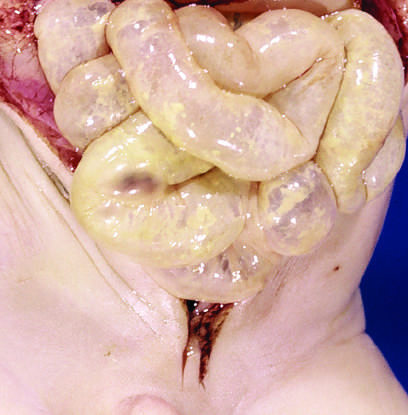what implies impending perforation?
Answer the question using a single word or phrase. The entire small bowel was markedly distended and perilously thin 